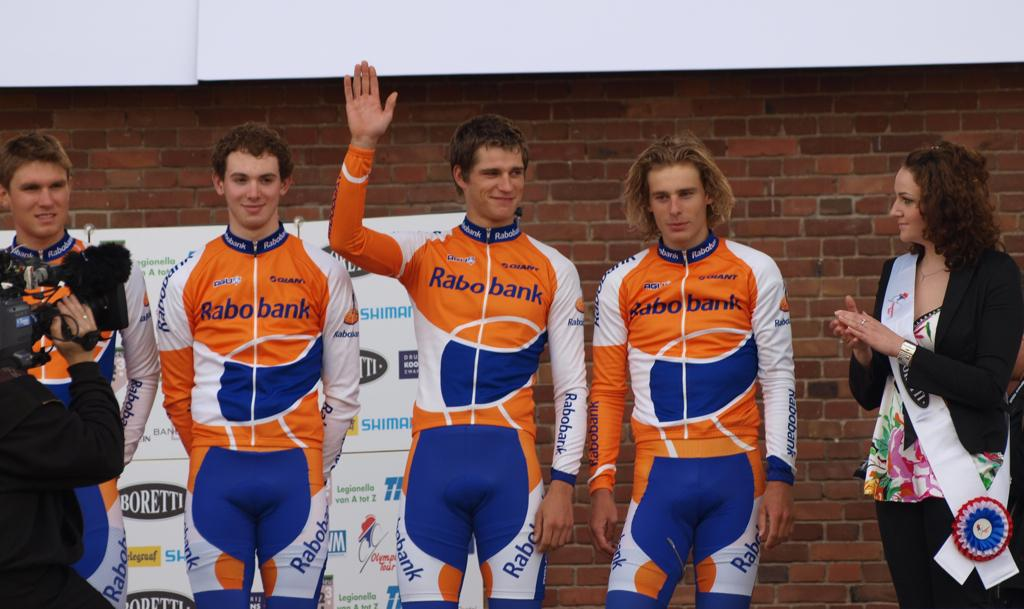<image>
Relay a brief, clear account of the picture shown. an orange outfit with the word Rabo Bank on it 